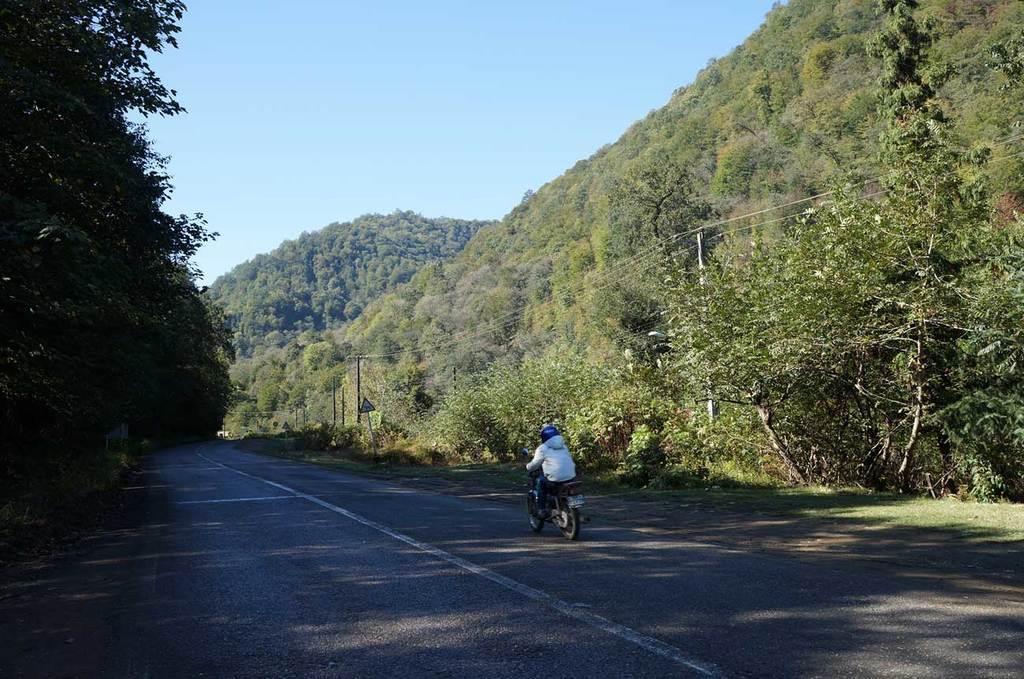In one or two sentences, can you explain what this image depicts? In this image there is a person riding a bike on the road, on the either side of the road there are trees, sign boards and electrical poles with cables on it. 